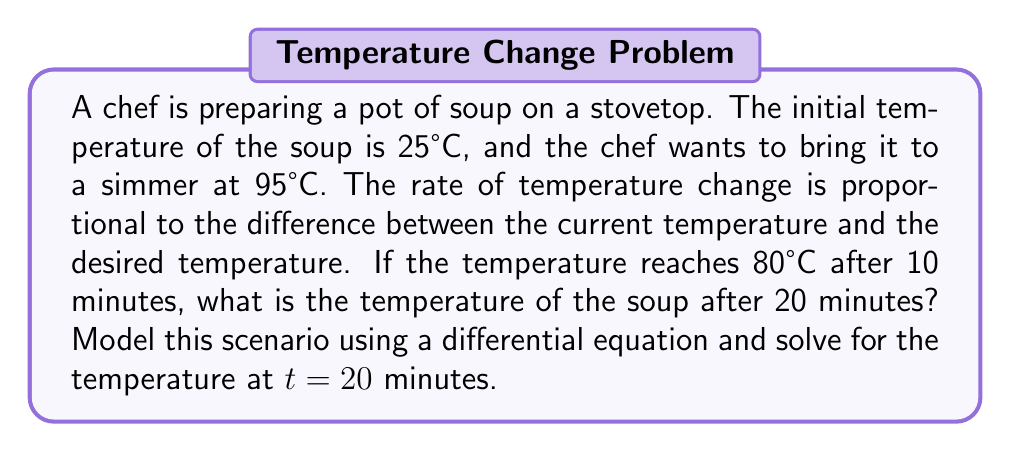Can you solve this math problem? 1. Let's define our variables:
   $T(t)$ = temperature of the soup at time $t$ (in minutes)
   $T_0$ = initial temperature = 25°C
   $T_f$ = final (desired) temperature = 95°C

2. The differential equation modeling this scenario is:
   $$\frac{dT}{dt} = k(T_f - T)$$
   where $k$ is the proportionality constant.

3. The solution to this differential equation is:
   $$T(t) = T_f - (T_f - T_0)e^{-kt}$$

4. We know that at $t = 10$ minutes, $T = 80°C$. Let's use this to find $k$:
   $$80 = 95 - (95 - 25)e^{-10k}$$
   $$15 = 70e^{-10k}$$
   $$\ln(\frac{15}{70}) = -10k$$
   $$k = -\frac{1}{10}\ln(\frac{3}{14}) \approx 0.1535$$

5. Now we can substitute this value of $k$ back into our solution:
   $$T(t) = 95 - 70e^{-0.1535t}$$

6. To find the temperature at $t = 20$ minutes, we simply plug in 20:
   $$T(20) = 95 - 70e^{-0.1535(20)} \approx 90.8°C$$
Answer: 90.8°C 